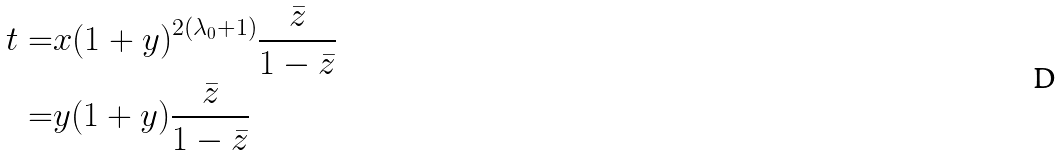<formula> <loc_0><loc_0><loc_500><loc_500>t = & x ( 1 + y ) ^ { 2 ( \lambda _ { 0 } + 1 ) } \frac { \bar { z } } { 1 - \bar { z } } \\ = & y ( 1 + y ) \frac { \bar { z } } { 1 - \bar { z } }</formula> 